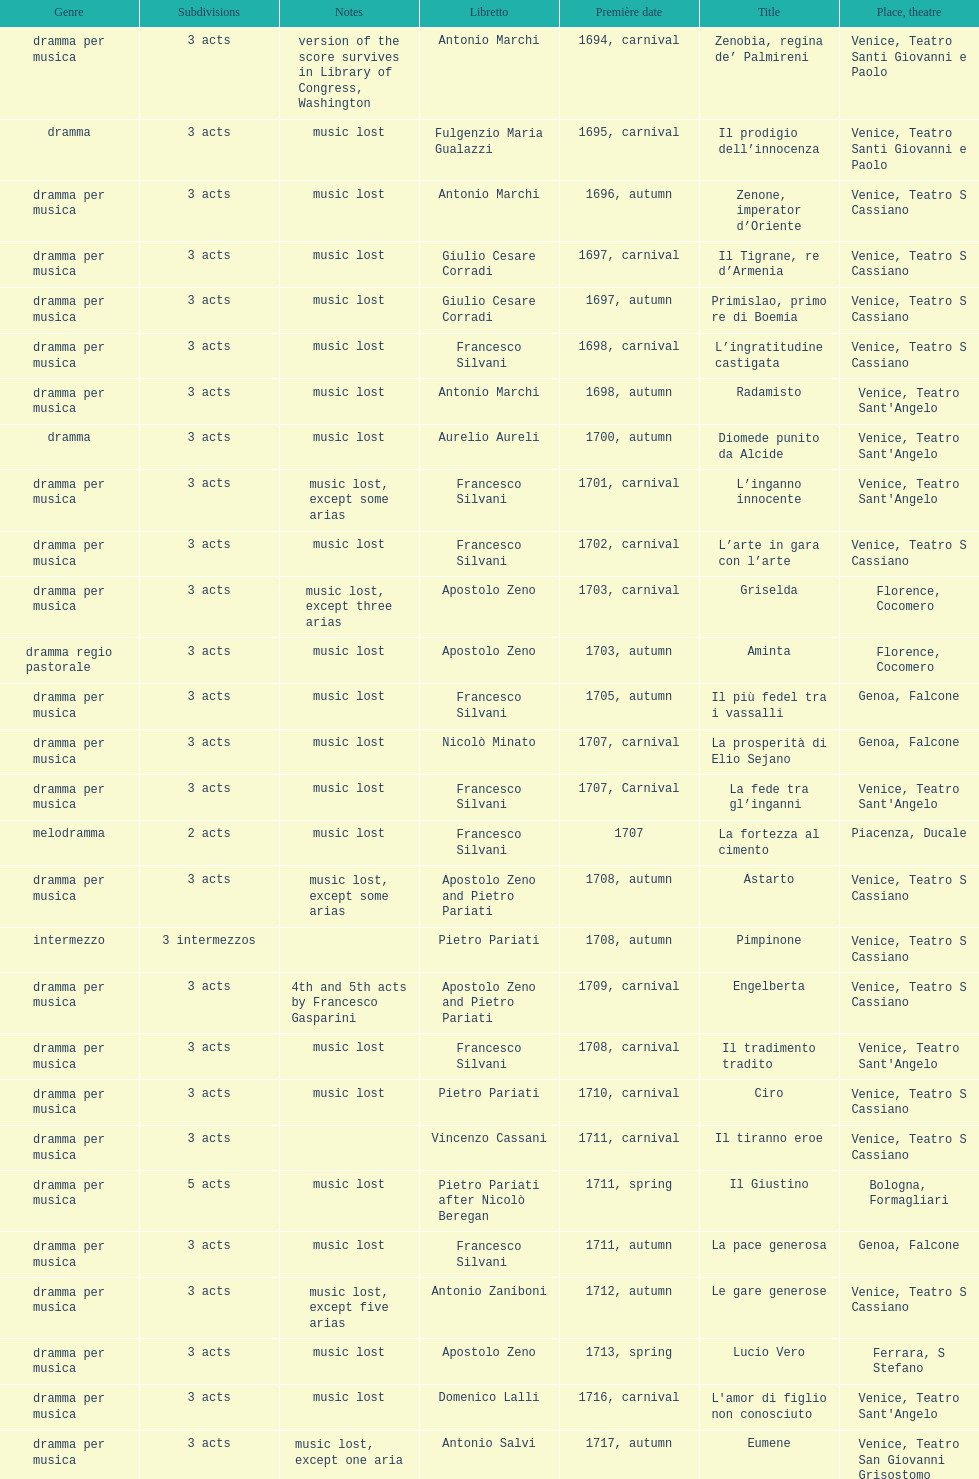What is next after ardelinda? Candalide. 